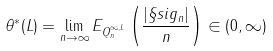Convert formula to latex. <formula><loc_0><loc_0><loc_500><loc_500>\theta ^ { * } ( L ) = \lim _ { n \to \infty } E _ { Q _ { n } ^ { \infty , L } } \left ( \frac { | \S s i g _ { n } | } { n } \right ) \in ( 0 , \infty )</formula> 